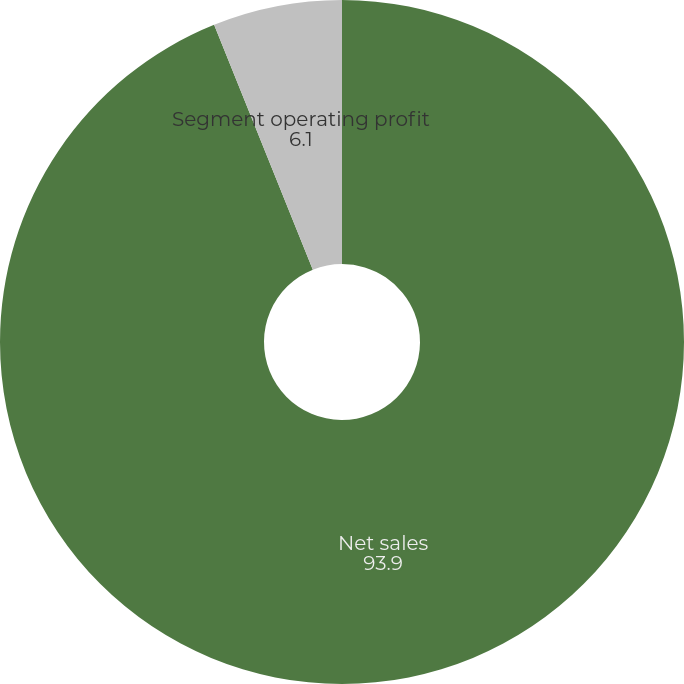Convert chart. <chart><loc_0><loc_0><loc_500><loc_500><pie_chart><fcel>Net sales<fcel>Segment operating profit<nl><fcel>93.9%<fcel>6.1%<nl></chart> 